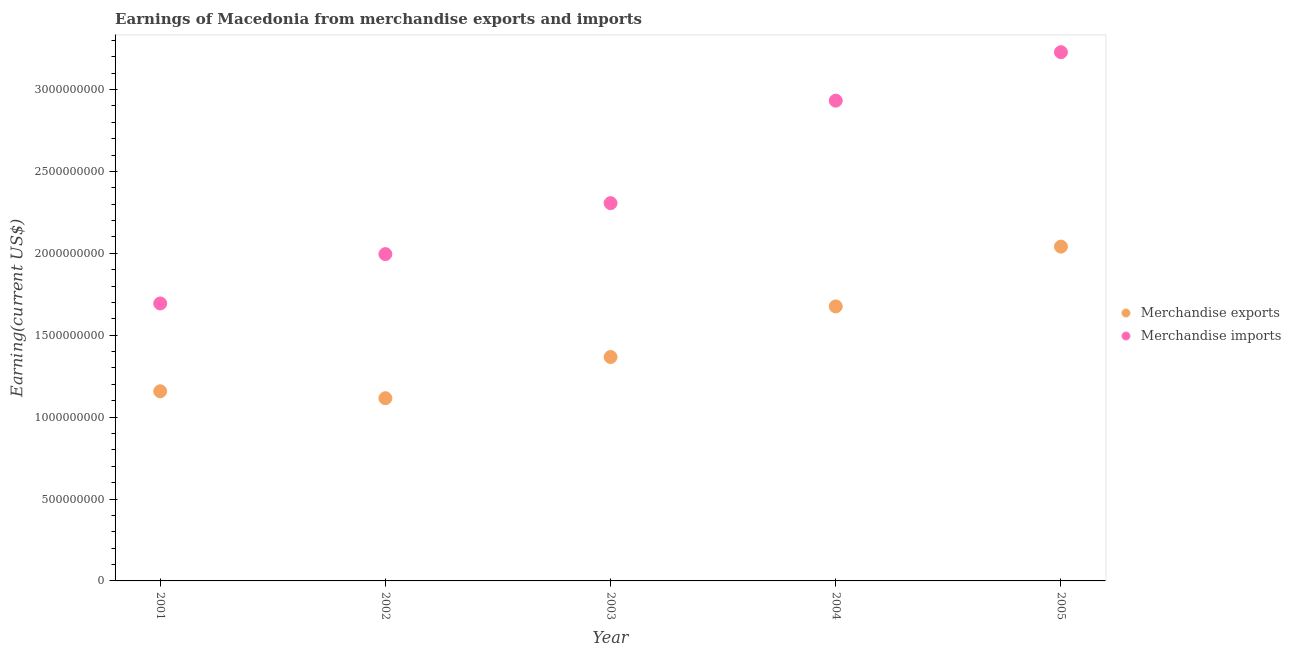What is the earnings from merchandise imports in 2002?
Your answer should be compact. 2.00e+09. Across all years, what is the maximum earnings from merchandise imports?
Ensure brevity in your answer.  3.23e+09. Across all years, what is the minimum earnings from merchandise exports?
Give a very brief answer. 1.12e+09. In which year was the earnings from merchandise exports maximum?
Offer a very short reply. 2005. In which year was the earnings from merchandise imports minimum?
Give a very brief answer. 2001. What is the total earnings from merchandise imports in the graph?
Provide a short and direct response. 1.22e+1. What is the difference between the earnings from merchandise exports in 2001 and that in 2004?
Provide a succinct answer. -5.18e+08. What is the difference between the earnings from merchandise exports in 2002 and the earnings from merchandise imports in 2004?
Provide a succinct answer. -1.82e+09. What is the average earnings from merchandise imports per year?
Provide a succinct answer. 2.43e+09. In the year 2002, what is the difference between the earnings from merchandise imports and earnings from merchandise exports?
Your answer should be compact. 8.80e+08. What is the ratio of the earnings from merchandise exports in 2004 to that in 2005?
Your answer should be very brief. 0.82. Is the difference between the earnings from merchandise exports in 2003 and 2005 greater than the difference between the earnings from merchandise imports in 2003 and 2005?
Provide a short and direct response. Yes. What is the difference between the highest and the second highest earnings from merchandise imports?
Your answer should be very brief. 2.96e+08. What is the difference between the highest and the lowest earnings from merchandise exports?
Keep it short and to the point. 9.25e+08. In how many years, is the earnings from merchandise imports greater than the average earnings from merchandise imports taken over all years?
Give a very brief answer. 2. Does the earnings from merchandise imports monotonically increase over the years?
Make the answer very short. Yes. Is the earnings from merchandise imports strictly greater than the earnings from merchandise exports over the years?
Offer a terse response. Yes. How many years are there in the graph?
Offer a very short reply. 5. What is the difference between two consecutive major ticks on the Y-axis?
Provide a succinct answer. 5.00e+08. Are the values on the major ticks of Y-axis written in scientific E-notation?
Your answer should be very brief. No. What is the title of the graph?
Provide a succinct answer. Earnings of Macedonia from merchandise exports and imports. What is the label or title of the X-axis?
Ensure brevity in your answer.  Year. What is the label or title of the Y-axis?
Your answer should be compact. Earning(current US$). What is the Earning(current US$) of Merchandise exports in 2001?
Ensure brevity in your answer.  1.16e+09. What is the Earning(current US$) of Merchandise imports in 2001?
Keep it short and to the point. 1.69e+09. What is the Earning(current US$) in Merchandise exports in 2002?
Keep it short and to the point. 1.12e+09. What is the Earning(current US$) in Merchandise imports in 2002?
Offer a terse response. 2.00e+09. What is the Earning(current US$) in Merchandise exports in 2003?
Make the answer very short. 1.37e+09. What is the Earning(current US$) in Merchandise imports in 2003?
Keep it short and to the point. 2.31e+09. What is the Earning(current US$) in Merchandise exports in 2004?
Your answer should be compact. 1.68e+09. What is the Earning(current US$) in Merchandise imports in 2004?
Your response must be concise. 2.93e+09. What is the Earning(current US$) of Merchandise exports in 2005?
Make the answer very short. 2.04e+09. What is the Earning(current US$) in Merchandise imports in 2005?
Keep it short and to the point. 3.23e+09. Across all years, what is the maximum Earning(current US$) of Merchandise exports?
Keep it short and to the point. 2.04e+09. Across all years, what is the maximum Earning(current US$) in Merchandise imports?
Your response must be concise. 3.23e+09. Across all years, what is the minimum Earning(current US$) in Merchandise exports?
Give a very brief answer. 1.12e+09. Across all years, what is the minimum Earning(current US$) of Merchandise imports?
Keep it short and to the point. 1.69e+09. What is the total Earning(current US$) in Merchandise exports in the graph?
Keep it short and to the point. 7.36e+09. What is the total Earning(current US$) of Merchandise imports in the graph?
Offer a very short reply. 1.22e+1. What is the difference between the Earning(current US$) in Merchandise exports in 2001 and that in 2002?
Provide a short and direct response. 4.25e+07. What is the difference between the Earning(current US$) in Merchandise imports in 2001 and that in 2002?
Offer a terse response. -3.01e+08. What is the difference between the Earning(current US$) of Merchandise exports in 2001 and that in 2003?
Make the answer very short. -2.09e+08. What is the difference between the Earning(current US$) in Merchandise imports in 2001 and that in 2003?
Keep it short and to the point. -6.12e+08. What is the difference between the Earning(current US$) in Merchandise exports in 2001 and that in 2004?
Offer a very short reply. -5.18e+08. What is the difference between the Earning(current US$) in Merchandise imports in 2001 and that in 2004?
Your answer should be compact. -1.24e+09. What is the difference between the Earning(current US$) of Merchandise exports in 2001 and that in 2005?
Make the answer very short. -8.83e+08. What is the difference between the Earning(current US$) in Merchandise imports in 2001 and that in 2005?
Make the answer very short. -1.53e+09. What is the difference between the Earning(current US$) in Merchandise exports in 2002 and that in 2003?
Provide a succinct answer. -2.51e+08. What is the difference between the Earning(current US$) in Merchandise imports in 2002 and that in 2003?
Offer a very short reply. -3.11e+08. What is the difference between the Earning(current US$) in Merchandise exports in 2002 and that in 2004?
Your answer should be compact. -5.60e+08. What is the difference between the Earning(current US$) in Merchandise imports in 2002 and that in 2004?
Keep it short and to the point. -9.37e+08. What is the difference between the Earning(current US$) in Merchandise exports in 2002 and that in 2005?
Make the answer very short. -9.25e+08. What is the difference between the Earning(current US$) of Merchandise imports in 2002 and that in 2005?
Your answer should be compact. -1.23e+09. What is the difference between the Earning(current US$) of Merchandise exports in 2003 and that in 2004?
Your answer should be compact. -3.09e+08. What is the difference between the Earning(current US$) of Merchandise imports in 2003 and that in 2004?
Ensure brevity in your answer.  -6.26e+08. What is the difference between the Earning(current US$) of Merchandise exports in 2003 and that in 2005?
Provide a short and direct response. -6.74e+08. What is the difference between the Earning(current US$) of Merchandise imports in 2003 and that in 2005?
Your answer should be compact. -9.22e+08. What is the difference between the Earning(current US$) in Merchandise exports in 2004 and that in 2005?
Your response must be concise. -3.65e+08. What is the difference between the Earning(current US$) in Merchandise imports in 2004 and that in 2005?
Offer a very short reply. -2.96e+08. What is the difference between the Earning(current US$) of Merchandise exports in 2001 and the Earning(current US$) of Merchandise imports in 2002?
Provide a short and direct response. -8.37e+08. What is the difference between the Earning(current US$) in Merchandise exports in 2001 and the Earning(current US$) in Merchandise imports in 2003?
Keep it short and to the point. -1.15e+09. What is the difference between the Earning(current US$) of Merchandise exports in 2001 and the Earning(current US$) of Merchandise imports in 2004?
Offer a terse response. -1.77e+09. What is the difference between the Earning(current US$) of Merchandise exports in 2001 and the Earning(current US$) of Merchandise imports in 2005?
Your answer should be very brief. -2.07e+09. What is the difference between the Earning(current US$) of Merchandise exports in 2002 and the Earning(current US$) of Merchandise imports in 2003?
Your answer should be compact. -1.19e+09. What is the difference between the Earning(current US$) in Merchandise exports in 2002 and the Earning(current US$) in Merchandise imports in 2004?
Your response must be concise. -1.82e+09. What is the difference between the Earning(current US$) in Merchandise exports in 2002 and the Earning(current US$) in Merchandise imports in 2005?
Provide a short and direct response. -2.11e+09. What is the difference between the Earning(current US$) in Merchandise exports in 2003 and the Earning(current US$) in Merchandise imports in 2004?
Your answer should be very brief. -1.57e+09. What is the difference between the Earning(current US$) of Merchandise exports in 2003 and the Earning(current US$) of Merchandise imports in 2005?
Your answer should be compact. -1.86e+09. What is the difference between the Earning(current US$) of Merchandise exports in 2004 and the Earning(current US$) of Merchandise imports in 2005?
Ensure brevity in your answer.  -1.55e+09. What is the average Earning(current US$) of Merchandise exports per year?
Provide a short and direct response. 1.47e+09. What is the average Earning(current US$) in Merchandise imports per year?
Your answer should be compact. 2.43e+09. In the year 2001, what is the difference between the Earning(current US$) in Merchandise exports and Earning(current US$) in Merchandise imports?
Provide a short and direct response. -5.36e+08. In the year 2002, what is the difference between the Earning(current US$) in Merchandise exports and Earning(current US$) in Merchandise imports?
Your response must be concise. -8.80e+08. In the year 2003, what is the difference between the Earning(current US$) of Merchandise exports and Earning(current US$) of Merchandise imports?
Your answer should be very brief. -9.39e+08. In the year 2004, what is the difference between the Earning(current US$) of Merchandise exports and Earning(current US$) of Merchandise imports?
Your answer should be compact. -1.26e+09. In the year 2005, what is the difference between the Earning(current US$) of Merchandise exports and Earning(current US$) of Merchandise imports?
Your answer should be compact. -1.19e+09. What is the ratio of the Earning(current US$) in Merchandise exports in 2001 to that in 2002?
Your answer should be compact. 1.04. What is the ratio of the Earning(current US$) in Merchandise imports in 2001 to that in 2002?
Your response must be concise. 0.85. What is the ratio of the Earning(current US$) in Merchandise exports in 2001 to that in 2003?
Offer a very short reply. 0.85. What is the ratio of the Earning(current US$) of Merchandise imports in 2001 to that in 2003?
Your answer should be compact. 0.73. What is the ratio of the Earning(current US$) in Merchandise exports in 2001 to that in 2004?
Your response must be concise. 0.69. What is the ratio of the Earning(current US$) of Merchandise imports in 2001 to that in 2004?
Keep it short and to the point. 0.58. What is the ratio of the Earning(current US$) in Merchandise exports in 2001 to that in 2005?
Provide a short and direct response. 0.57. What is the ratio of the Earning(current US$) of Merchandise imports in 2001 to that in 2005?
Offer a terse response. 0.52. What is the ratio of the Earning(current US$) in Merchandise exports in 2002 to that in 2003?
Your answer should be compact. 0.82. What is the ratio of the Earning(current US$) of Merchandise imports in 2002 to that in 2003?
Your response must be concise. 0.87. What is the ratio of the Earning(current US$) in Merchandise exports in 2002 to that in 2004?
Ensure brevity in your answer.  0.67. What is the ratio of the Earning(current US$) of Merchandise imports in 2002 to that in 2004?
Ensure brevity in your answer.  0.68. What is the ratio of the Earning(current US$) in Merchandise exports in 2002 to that in 2005?
Your answer should be very brief. 0.55. What is the ratio of the Earning(current US$) in Merchandise imports in 2002 to that in 2005?
Provide a succinct answer. 0.62. What is the ratio of the Earning(current US$) in Merchandise exports in 2003 to that in 2004?
Offer a very short reply. 0.82. What is the ratio of the Earning(current US$) of Merchandise imports in 2003 to that in 2004?
Ensure brevity in your answer.  0.79. What is the ratio of the Earning(current US$) of Merchandise exports in 2003 to that in 2005?
Keep it short and to the point. 0.67. What is the ratio of the Earning(current US$) in Merchandise imports in 2003 to that in 2005?
Offer a terse response. 0.71. What is the ratio of the Earning(current US$) in Merchandise exports in 2004 to that in 2005?
Your answer should be very brief. 0.82. What is the ratio of the Earning(current US$) in Merchandise imports in 2004 to that in 2005?
Your answer should be compact. 0.91. What is the difference between the highest and the second highest Earning(current US$) in Merchandise exports?
Keep it short and to the point. 3.65e+08. What is the difference between the highest and the second highest Earning(current US$) in Merchandise imports?
Your answer should be compact. 2.96e+08. What is the difference between the highest and the lowest Earning(current US$) of Merchandise exports?
Provide a succinct answer. 9.25e+08. What is the difference between the highest and the lowest Earning(current US$) in Merchandise imports?
Offer a very short reply. 1.53e+09. 